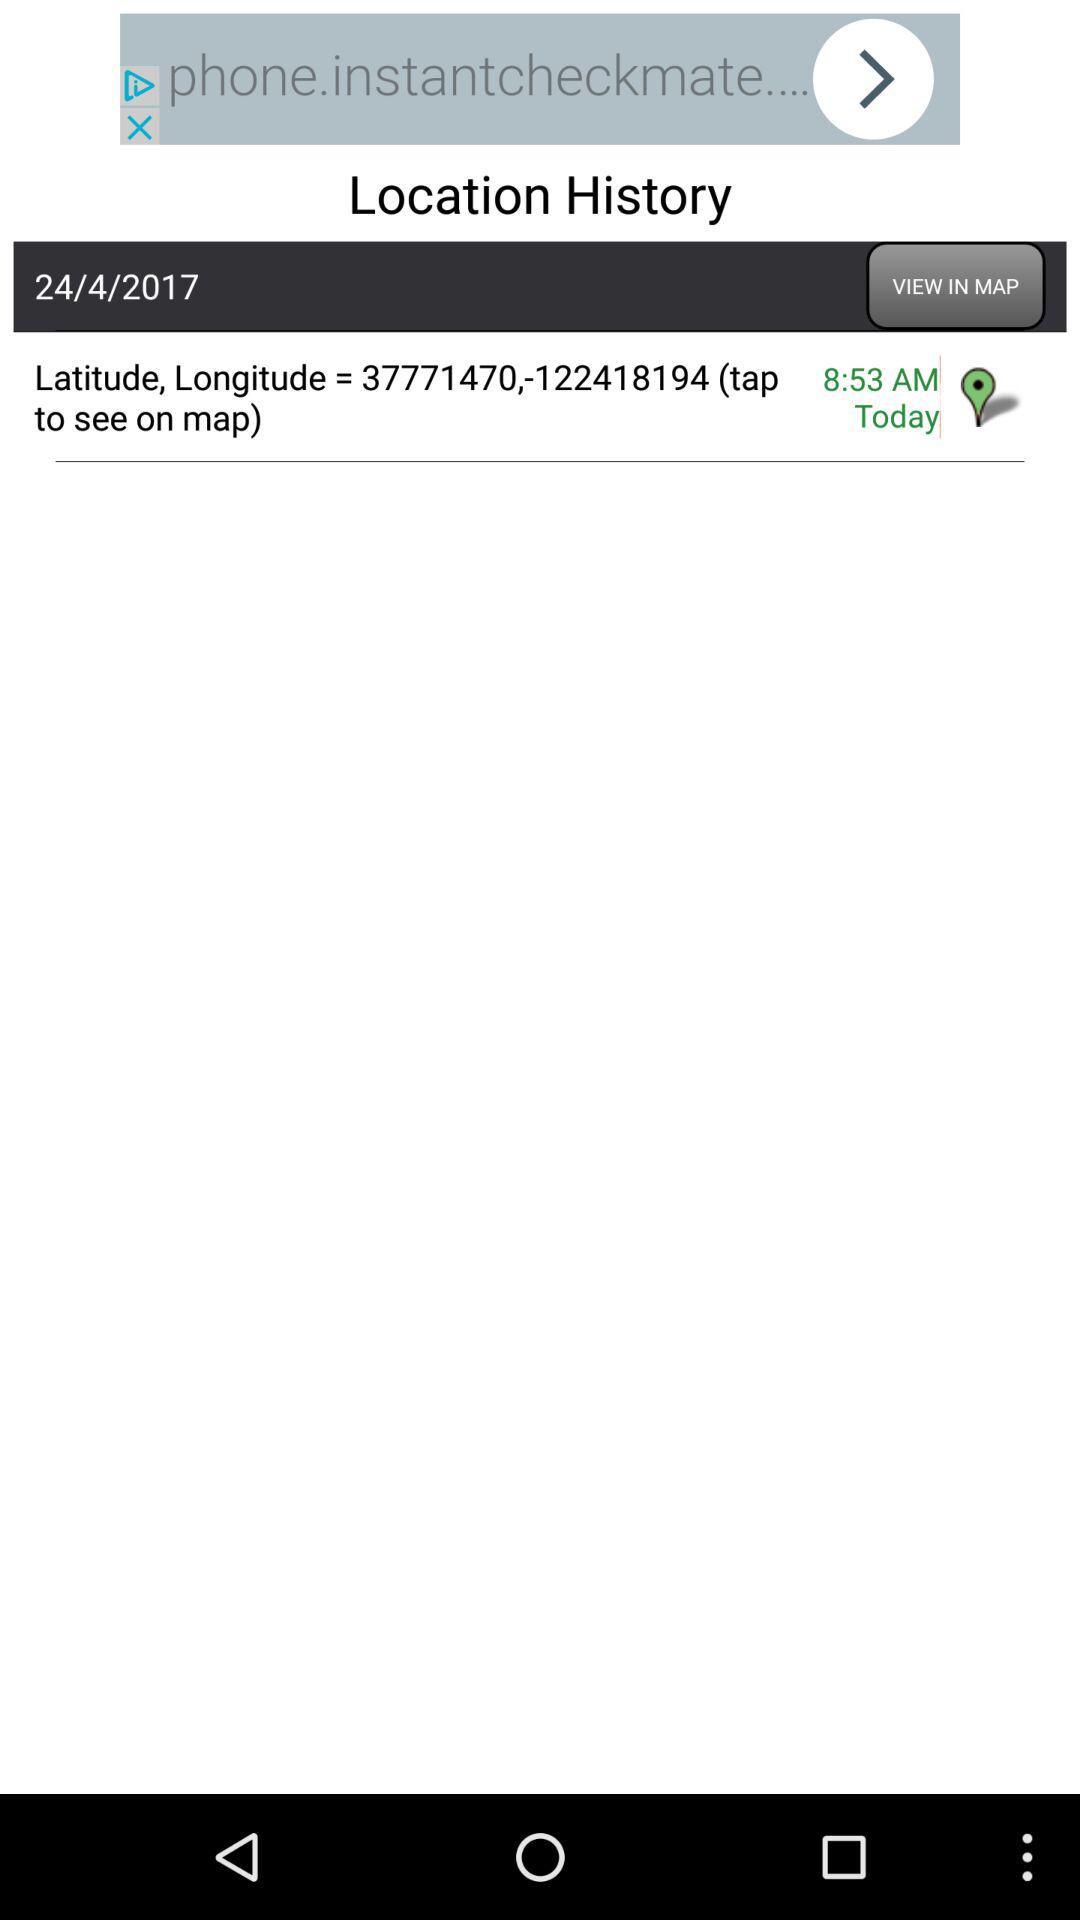What are the latitude & longitude? The latitude and longitude are 37771470 and -122418194 respectively. 